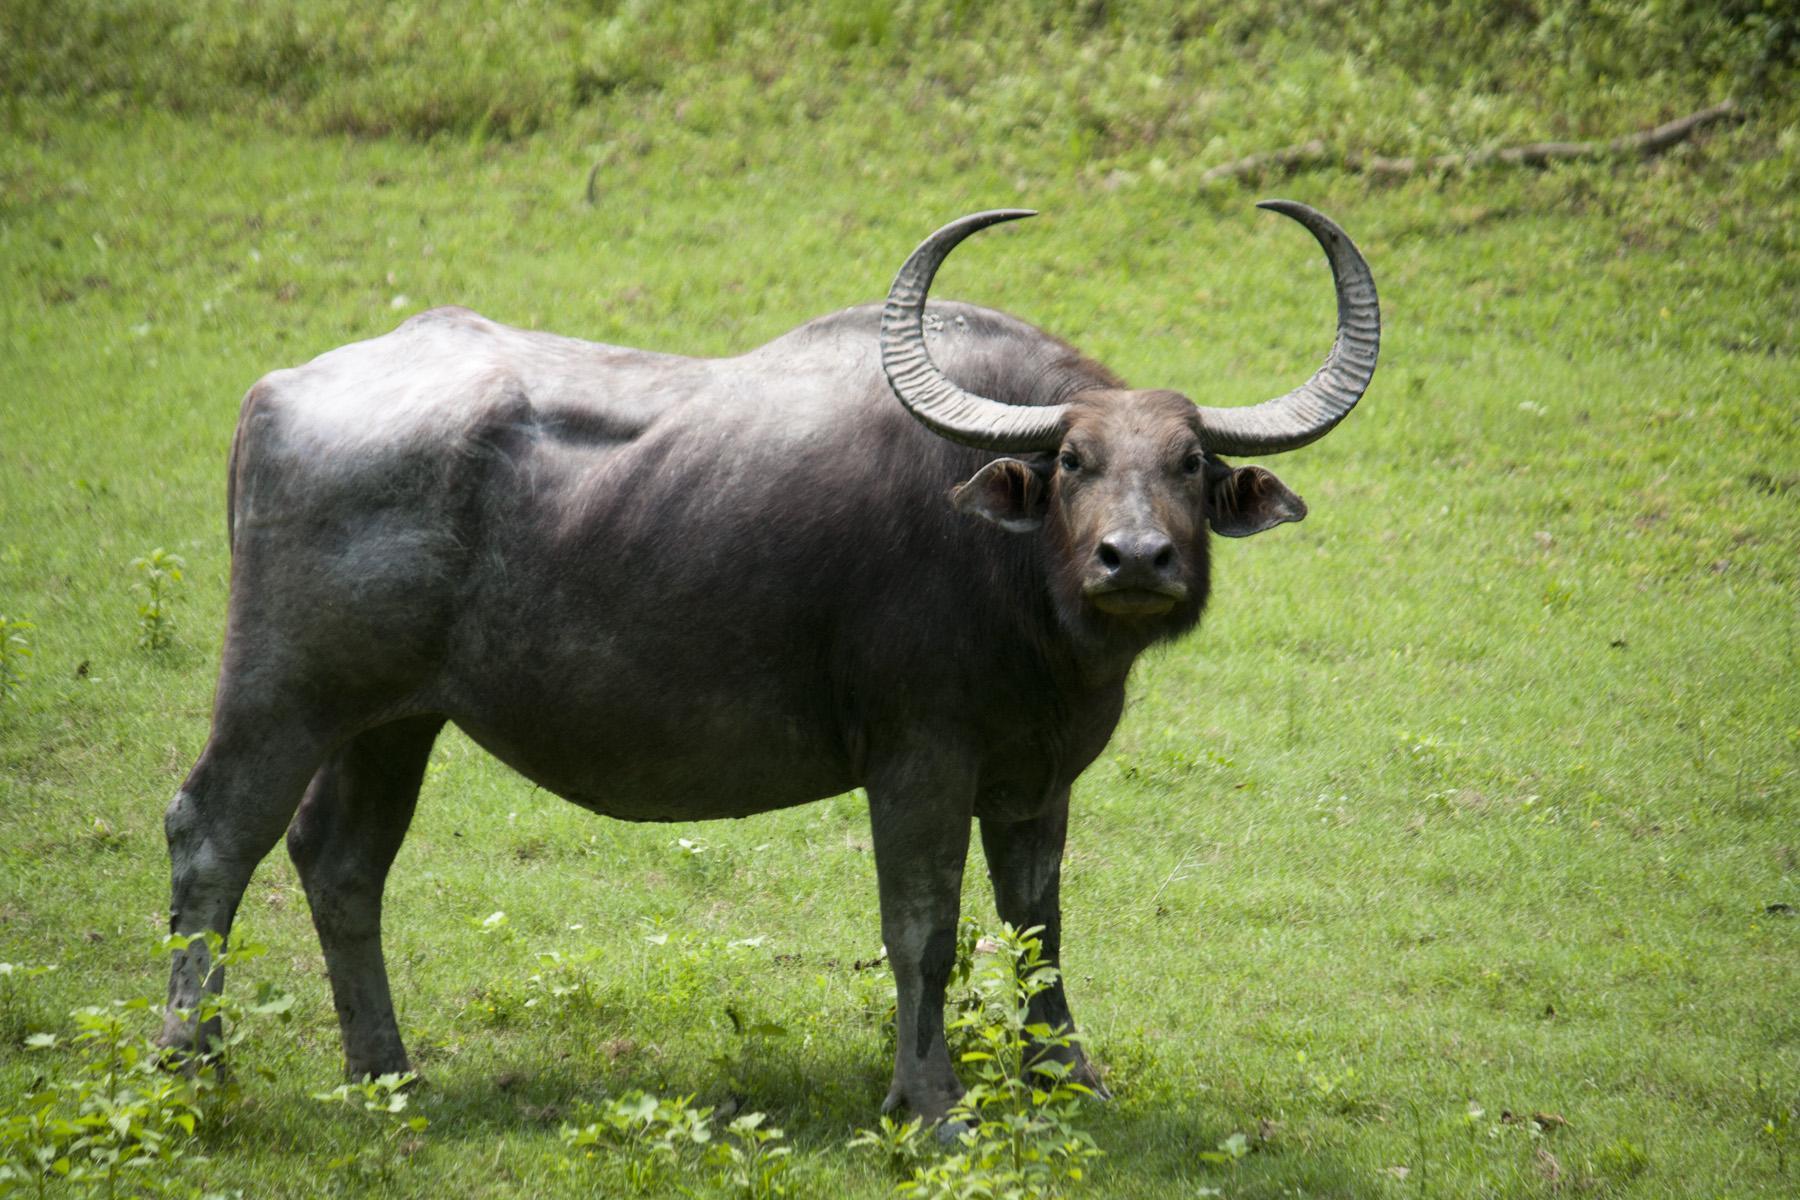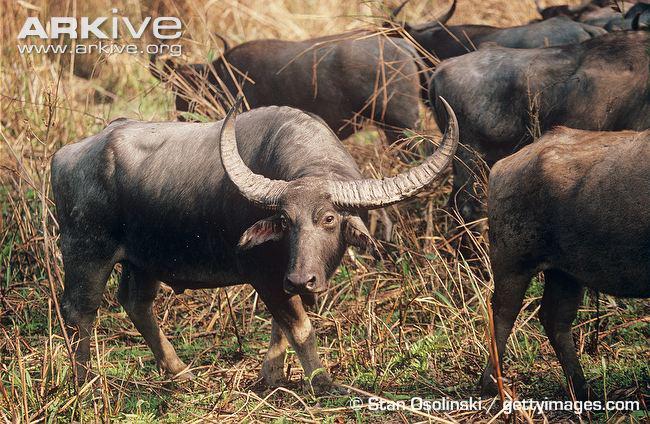The first image is the image on the left, the second image is the image on the right. Evaluate the accuracy of this statement regarding the images: "The image on the left contains only one water buffalo.". Is it true? Answer yes or no. Yes. The first image is the image on the left, the second image is the image on the right. Analyze the images presented: Is the assertion "Each set of images contains exactly three ruminants, regardless of specie-type." valid? Answer yes or no. No. 